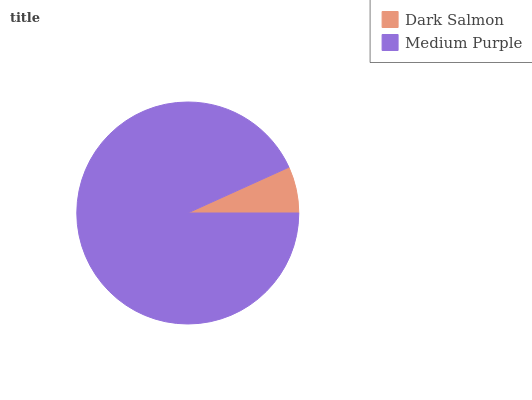Is Dark Salmon the minimum?
Answer yes or no. Yes. Is Medium Purple the maximum?
Answer yes or no. Yes. Is Medium Purple the minimum?
Answer yes or no. No. Is Medium Purple greater than Dark Salmon?
Answer yes or no. Yes. Is Dark Salmon less than Medium Purple?
Answer yes or no. Yes. Is Dark Salmon greater than Medium Purple?
Answer yes or no. No. Is Medium Purple less than Dark Salmon?
Answer yes or no. No. Is Medium Purple the high median?
Answer yes or no. Yes. Is Dark Salmon the low median?
Answer yes or no. Yes. Is Dark Salmon the high median?
Answer yes or no. No. Is Medium Purple the low median?
Answer yes or no. No. 